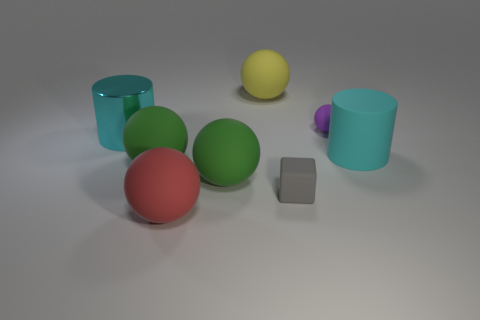Are there any purple rubber spheres of the same size as the gray rubber block?
Provide a short and direct response. Yes. What color is the large cylinder behind the cyan thing that is on the right side of the tiny object that is on the right side of the cube?
Your answer should be very brief. Cyan. Is the material of the gray object the same as the cyan cylinder on the left side of the big yellow rubber thing?
Your answer should be compact. No. There is a cyan shiny thing that is the same shape as the large cyan rubber thing; what size is it?
Provide a short and direct response. Large. Are there the same number of cyan metallic things that are in front of the large cyan shiny cylinder and matte objects that are in front of the yellow rubber thing?
Provide a short and direct response. No. How many other things are the same material as the red object?
Provide a short and direct response. 6. Are there the same number of cyan objects behind the purple sphere and yellow objects?
Provide a succinct answer. No. Do the purple rubber ball and the cyan object right of the large yellow rubber thing have the same size?
Give a very brief answer. No. What is the shape of the large rubber thing on the right side of the tiny gray matte thing?
Offer a very short reply. Cylinder. Are there any other things that have the same shape as the gray matte object?
Offer a very short reply. No. 